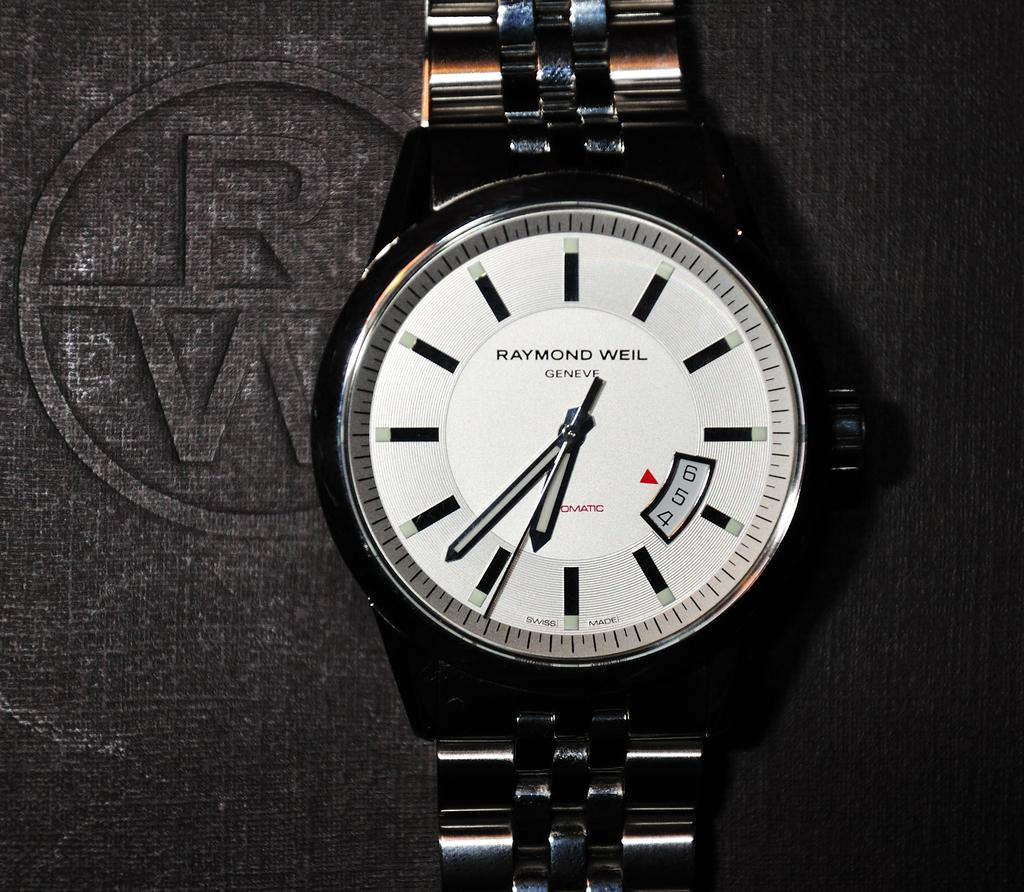<image>
Give a short and clear explanation of the subsequent image. A black and white Raymond Weil wrist watch. 